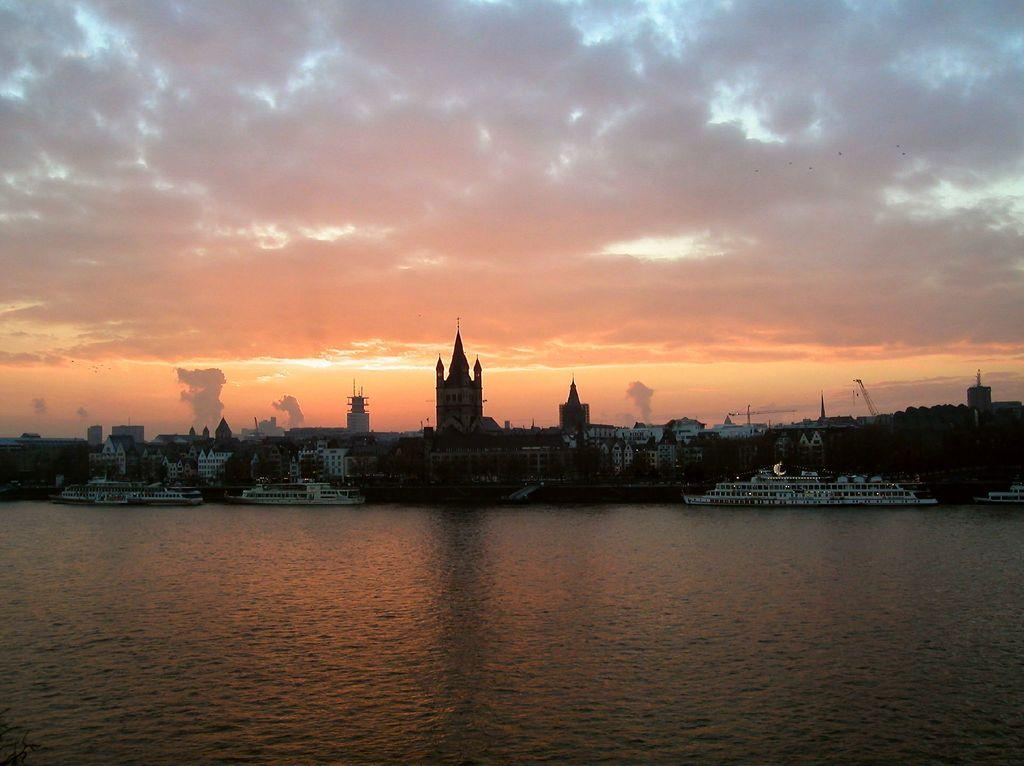What is the main subject of the image? The main subject of the image is three cruise ships. Where are the cruise ships located? The cruise ships are on the water. What else can be seen in the image besides the cruise ships? There are buildings visible in the image, and they are surrounded by trees. What is the condition of the sky in the image? The sky has clouds in the image. How many units of home appliances can be seen in the image? There are no home appliances present in the image. What type of hands are visible on the cruise ships in the image? There are no hands visible in the image; it features cruise ships on the water. 